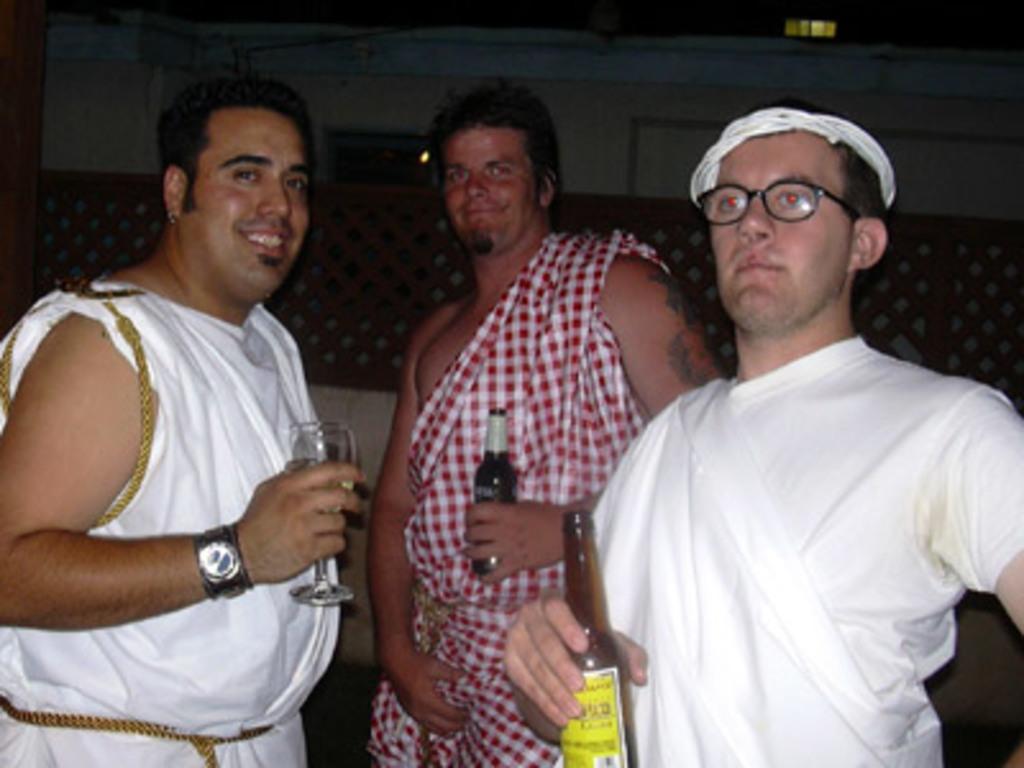Please provide a concise description of this image. In this image I can see 3 men standing. The person on the left is holding a wine glass and 2 other people are holding glass bottles. 